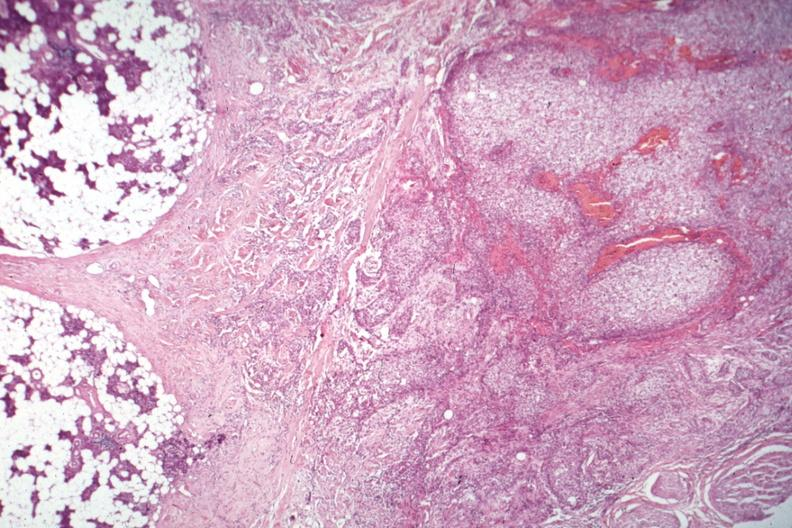what is present?
Answer the question using a single word or phrase. Mucoepidermoid carcinoma 